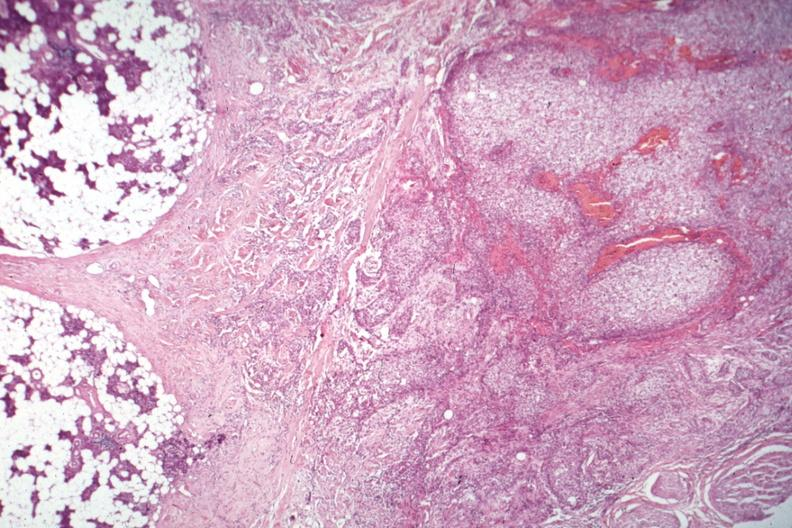what is present?
Answer the question using a single word or phrase. Mucoepidermoid carcinoma 